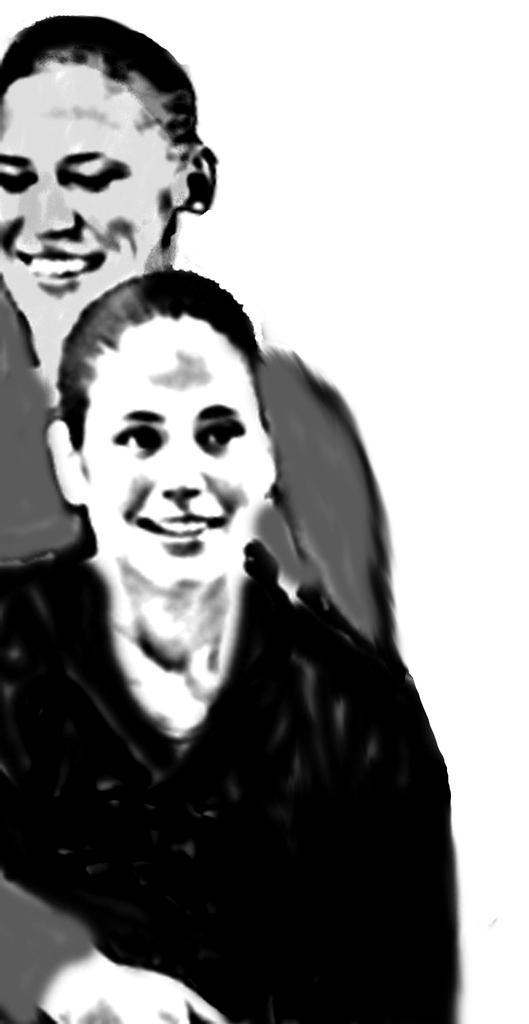In one or two sentences, can you explain what this image depicts? In the image we can see two women are smiling. 